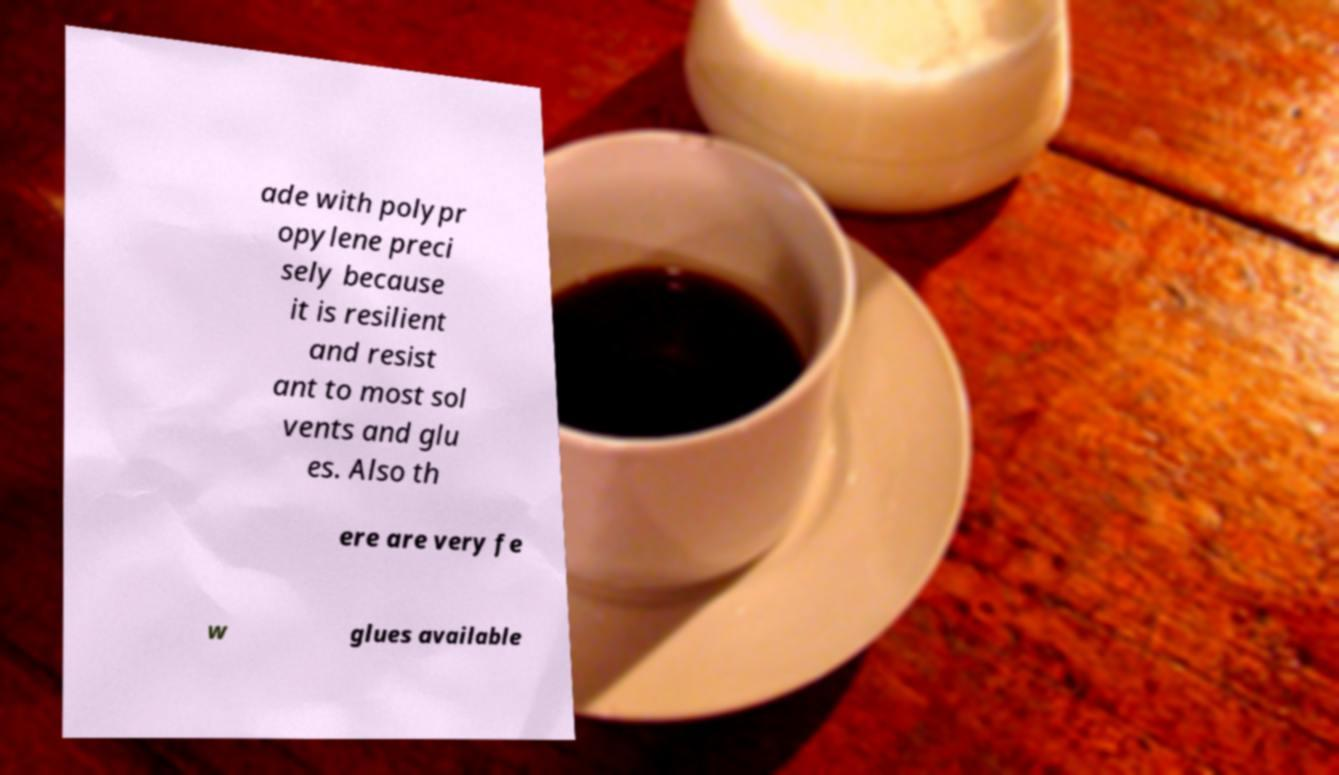Please read and relay the text visible in this image. What does it say? ade with polypr opylene preci sely because it is resilient and resist ant to most sol vents and glu es. Also th ere are very fe w glues available 